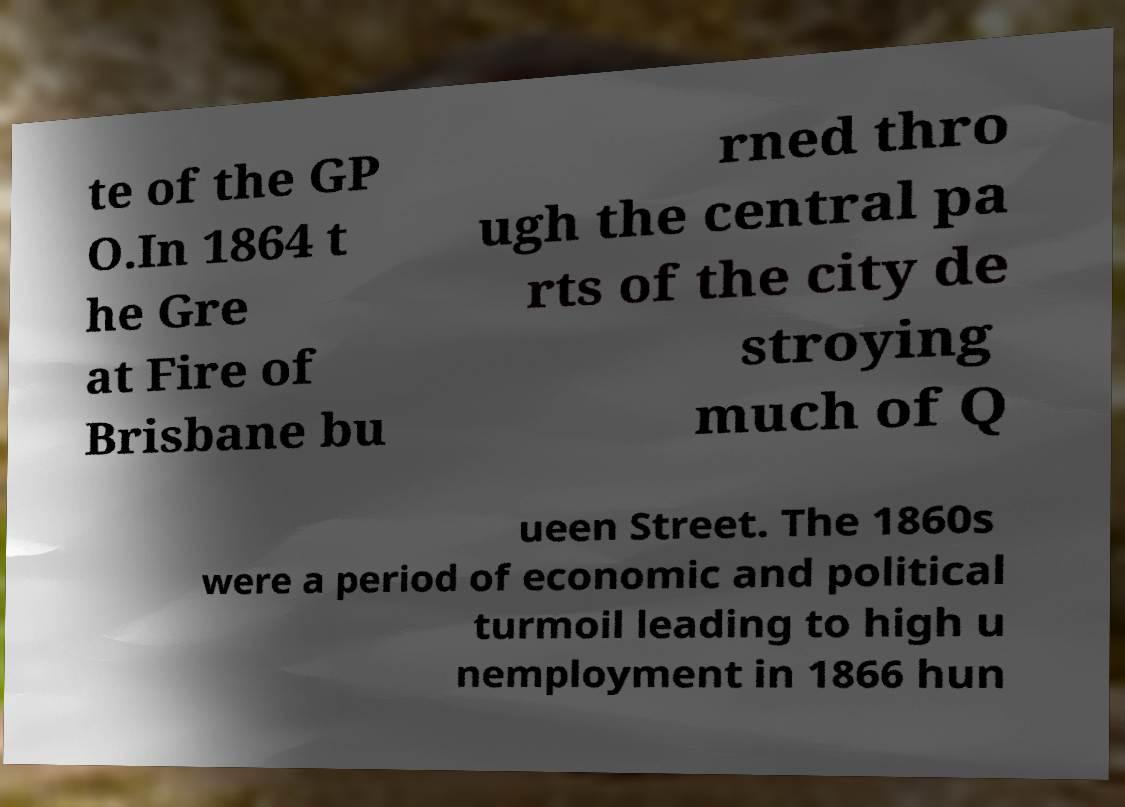Could you assist in decoding the text presented in this image and type it out clearly? te of the GP O.In 1864 t he Gre at Fire of Brisbane bu rned thro ugh the central pa rts of the city de stroying much of Q ueen Street. The 1860s were a period of economic and political turmoil leading to high u nemployment in 1866 hun 